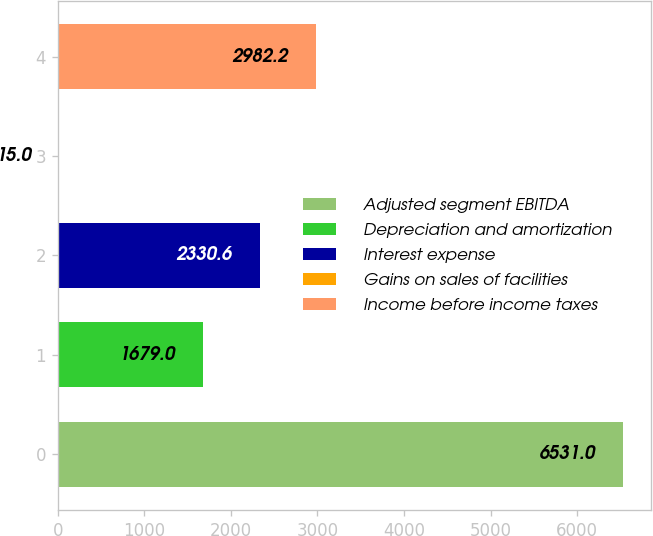<chart> <loc_0><loc_0><loc_500><loc_500><bar_chart><fcel>Adjusted segment EBITDA<fcel>Depreciation and amortization<fcel>Interest expense<fcel>Gains on sales of facilities<fcel>Income before income taxes<nl><fcel>6531<fcel>1679<fcel>2330.6<fcel>15<fcel>2982.2<nl></chart> 